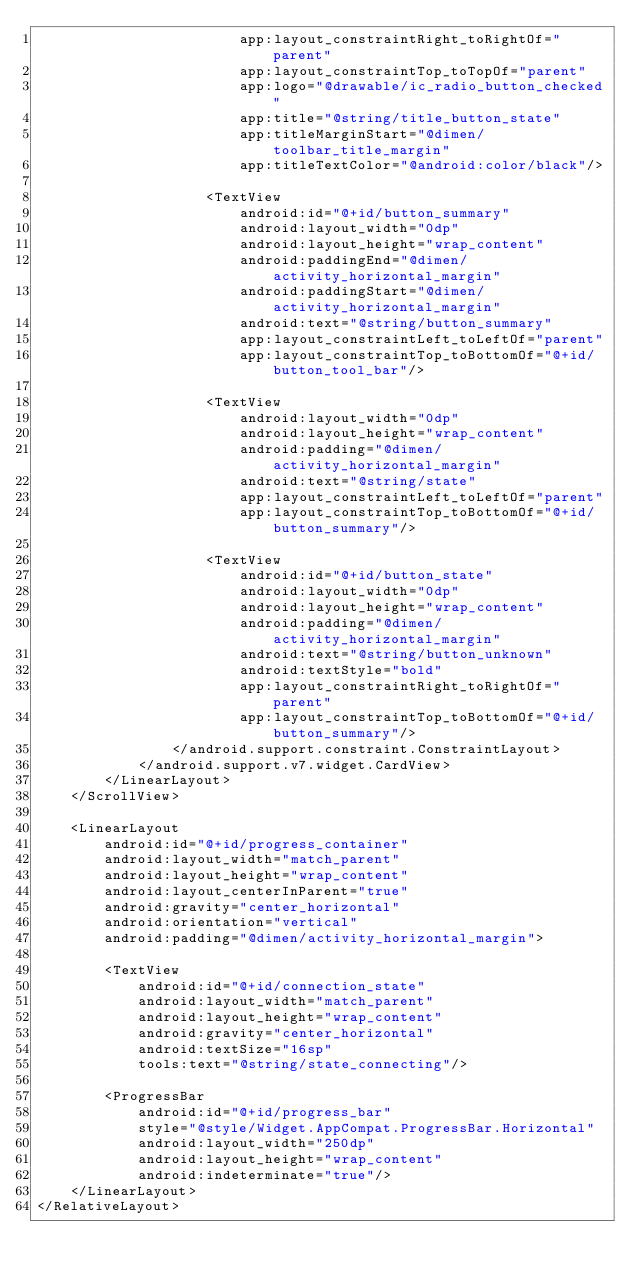Convert code to text. <code><loc_0><loc_0><loc_500><loc_500><_XML_>						app:layout_constraintRight_toRightOf="parent"
						app:layout_constraintTop_toTopOf="parent"
						app:logo="@drawable/ic_radio_button_checked"
						app:title="@string/title_button_state"
						app:titleMarginStart="@dimen/toolbar_title_margin"
						app:titleTextColor="@android:color/black"/>

					<TextView
						android:id="@+id/button_summary"
						android:layout_width="0dp"
						android:layout_height="wrap_content"
						android:paddingEnd="@dimen/activity_horizontal_margin"
						android:paddingStart="@dimen/activity_horizontal_margin"
						android:text="@string/button_summary"
						app:layout_constraintLeft_toLeftOf="parent"
						app:layout_constraintTop_toBottomOf="@+id/button_tool_bar"/>

					<TextView
						android:layout_width="0dp"
						android:layout_height="wrap_content"
						android:padding="@dimen/activity_horizontal_margin"
						android:text="@string/state"
						app:layout_constraintLeft_toLeftOf="parent"
						app:layout_constraintTop_toBottomOf="@+id/button_summary"/>

					<TextView
						android:id="@+id/button_state"
						android:layout_width="0dp"
						android:layout_height="wrap_content"
						android:padding="@dimen/activity_horizontal_margin"
						android:text="@string/button_unknown"
						android:textStyle="bold"
						app:layout_constraintRight_toRightOf="parent"
						app:layout_constraintTop_toBottomOf="@+id/button_summary"/>
				</android.support.constraint.ConstraintLayout>
			</android.support.v7.widget.CardView>
		</LinearLayout>
	</ScrollView>

	<LinearLayout
		android:id="@+id/progress_container"
		android:layout_width="match_parent"
		android:layout_height="wrap_content"
		android:layout_centerInParent="true"
		android:gravity="center_horizontal"
		android:orientation="vertical"
		android:padding="@dimen/activity_horizontal_margin">

		<TextView
			android:id="@+id/connection_state"
			android:layout_width="match_parent"
			android:layout_height="wrap_content"
			android:gravity="center_horizontal"
			android:textSize="16sp"
			tools:text="@string/state_connecting"/>

		<ProgressBar
			android:id="@+id/progress_bar"
			style="@style/Widget.AppCompat.ProgressBar.Horizontal"
			android:layout_width="250dp"
			android:layout_height="wrap_content"
			android:indeterminate="true"/>
	</LinearLayout>
</RelativeLayout></code> 